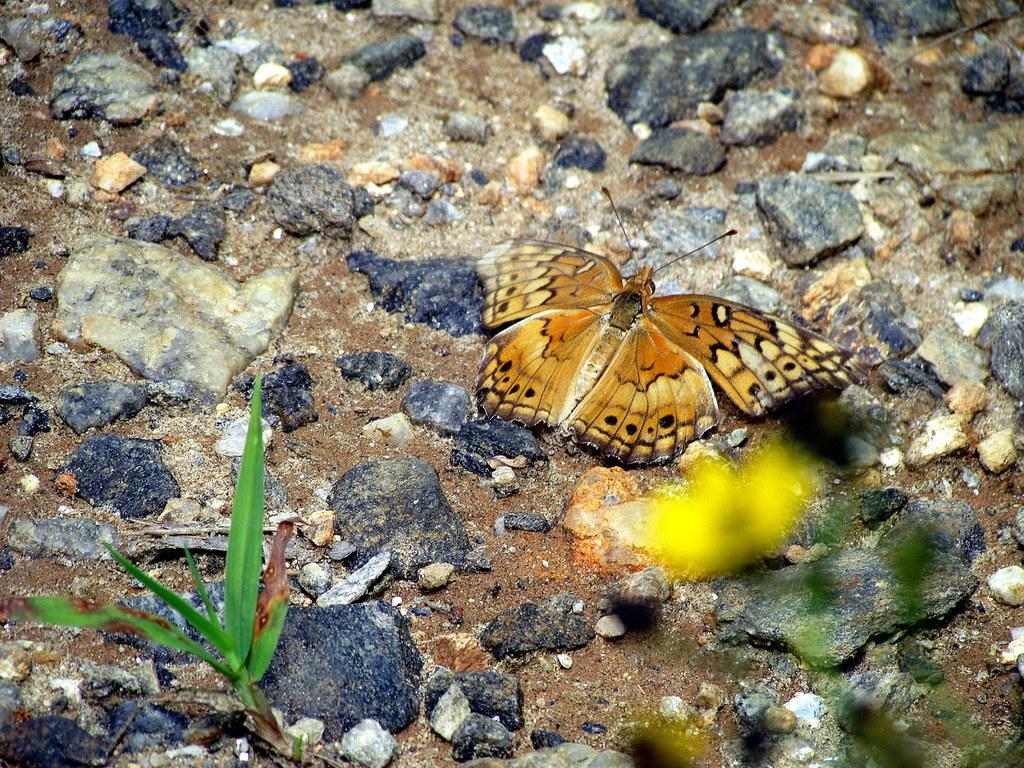What is on the ground in the image? There is a butterfly on the ground in the image. What type of vegetation can be seen in the image? There is grass visible in the image, and there is a flower on a plant. What other objects are present in the image? There are stones present in the image. How many sisters are playing with the cactus in the image? There are no sisters or cactus present in the image. 